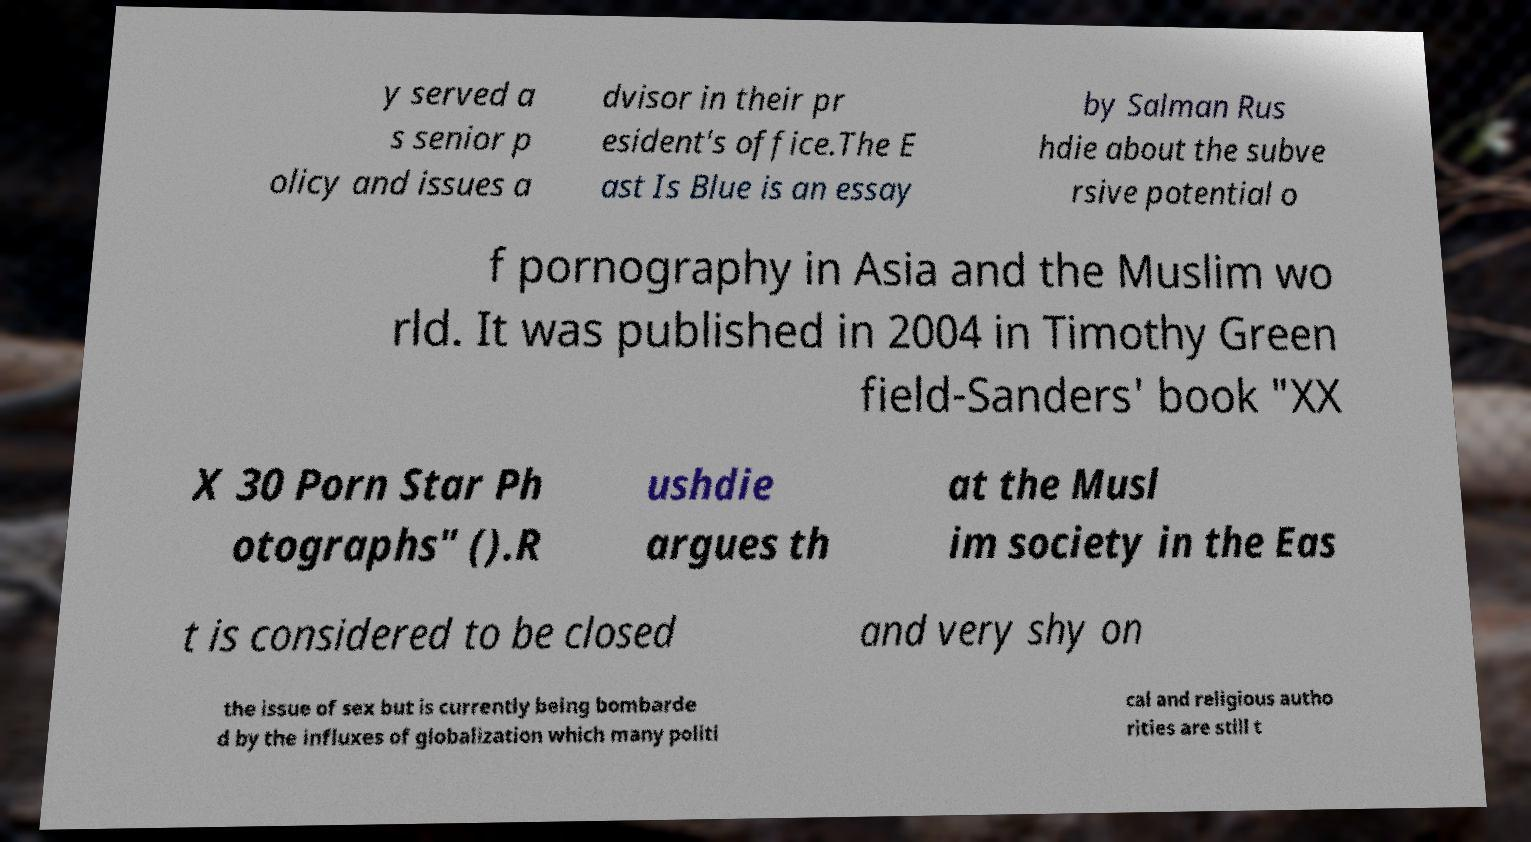What messages or text are displayed in this image? I need them in a readable, typed format. y served a s senior p olicy and issues a dvisor in their pr esident's office.The E ast Is Blue is an essay by Salman Rus hdie about the subve rsive potential o f pornography in Asia and the Muslim wo rld. It was published in 2004 in Timothy Green field-Sanders' book "XX X 30 Porn Star Ph otographs" ().R ushdie argues th at the Musl im society in the Eas t is considered to be closed and very shy on the issue of sex but is currently being bombarde d by the influxes of globalization which many politi cal and religious autho rities are still t 